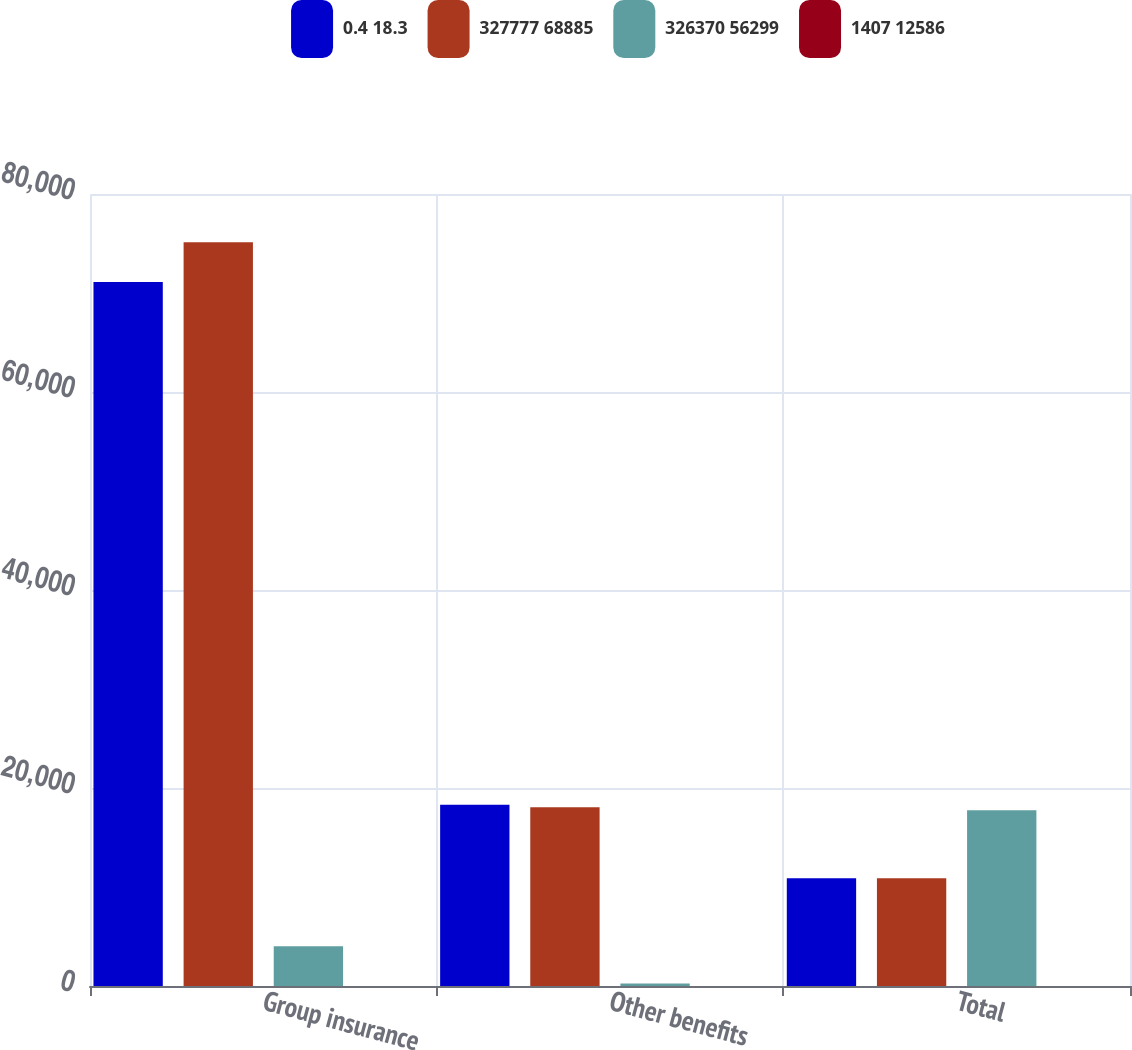<chart> <loc_0><loc_0><loc_500><loc_500><stacked_bar_chart><ecel><fcel>Group insurance<fcel>Other benefits<fcel>Total<nl><fcel>0.4 18.3<fcel>71103<fcel>18303<fcel>10889<nl><fcel>327777 68885<fcel>75120<fcel>18054<fcel>10889<nl><fcel>326370 56299<fcel>4017<fcel>249<fcel>17761<nl><fcel>1407 12586<fcel>5.3<fcel>1.4<fcel>3.6<nl></chart> 